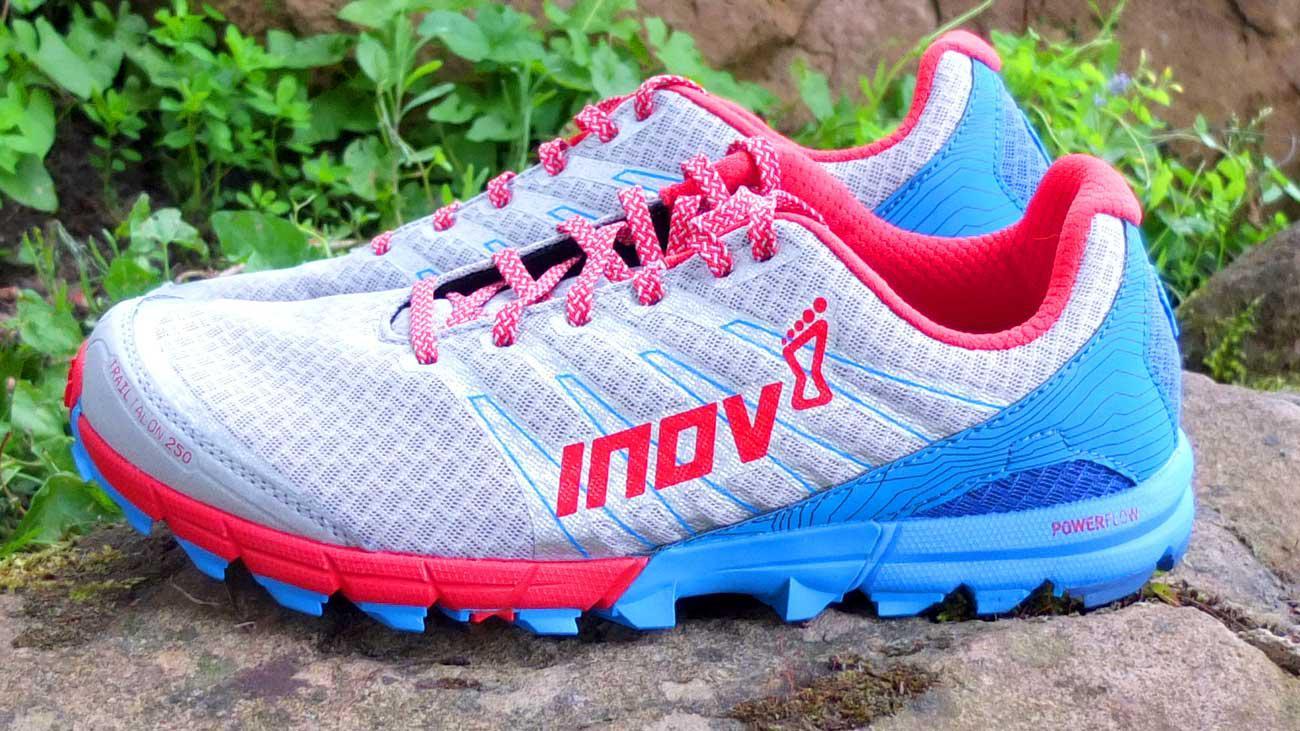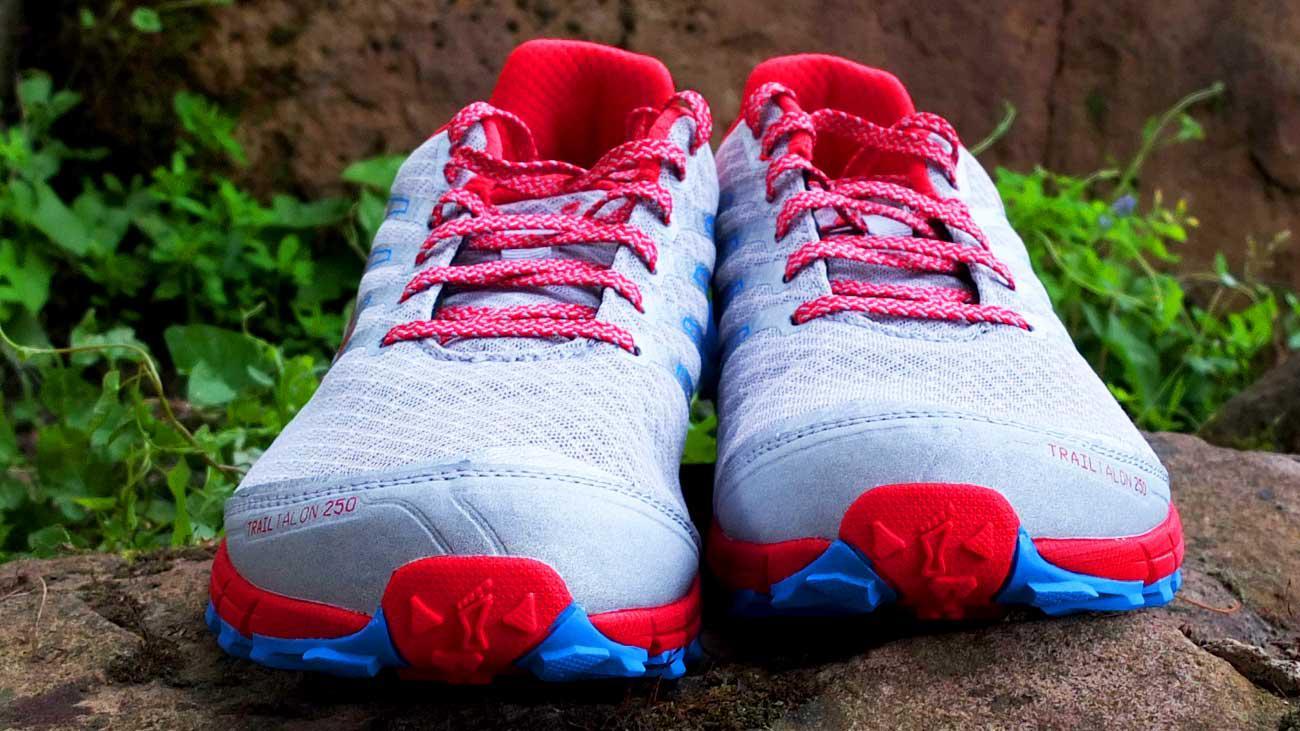The first image is the image on the left, the second image is the image on the right. Evaluate the accuracy of this statement regarding the images: "One of the shoes in one of the images is turned on its side.". Is it true? Answer yes or no. No. 